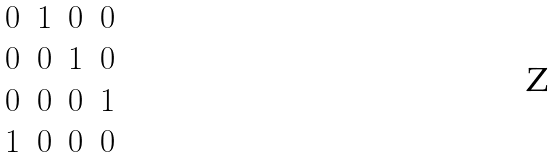Convert formula to latex. <formula><loc_0><loc_0><loc_500><loc_500>\begin{matrix} 0 & 1 & 0 & 0 \\ 0 & 0 & 1 & 0 \\ 0 & 0 & 0 & 1 \\ 1 & 0 & 0 & 0 \end{matrix}</formula> 